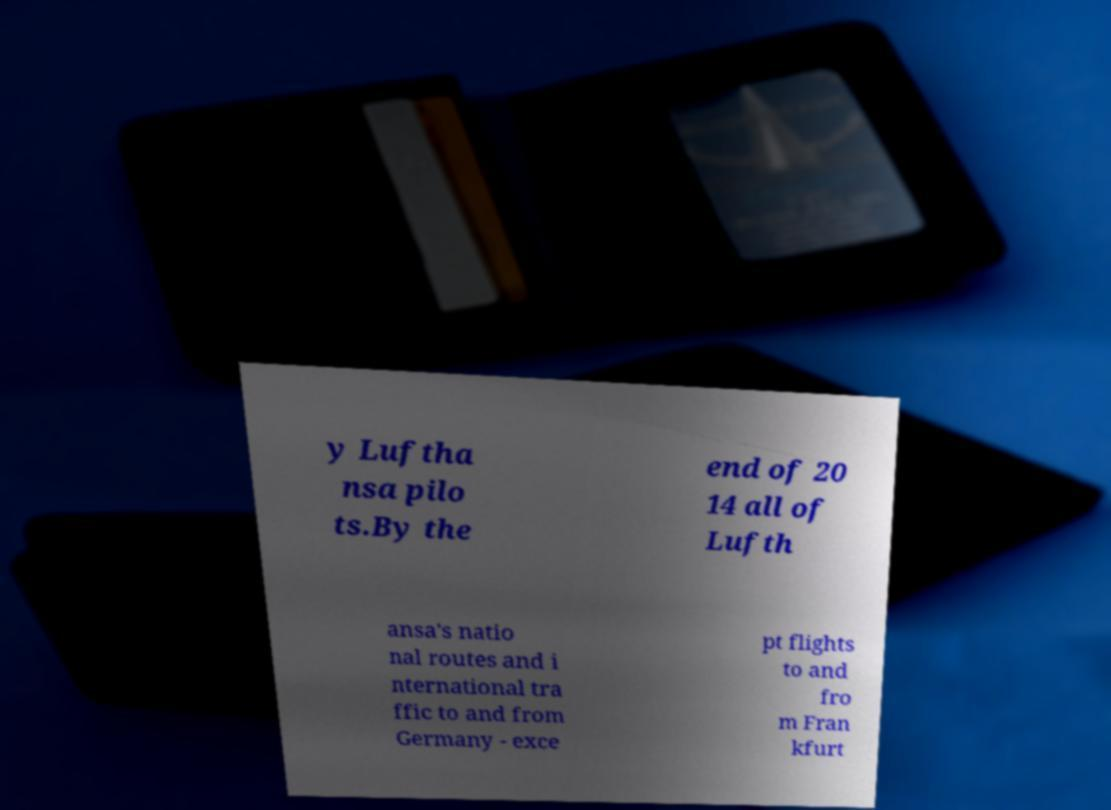Could you extract and type out the text from this image? y Luftha nsa pilo ts.By the end of 20 14 all of Lufth ansa's natio nal routes and i nternational tra ffic to and from Germany - exce pt flights to and fro m Fran kfurt 